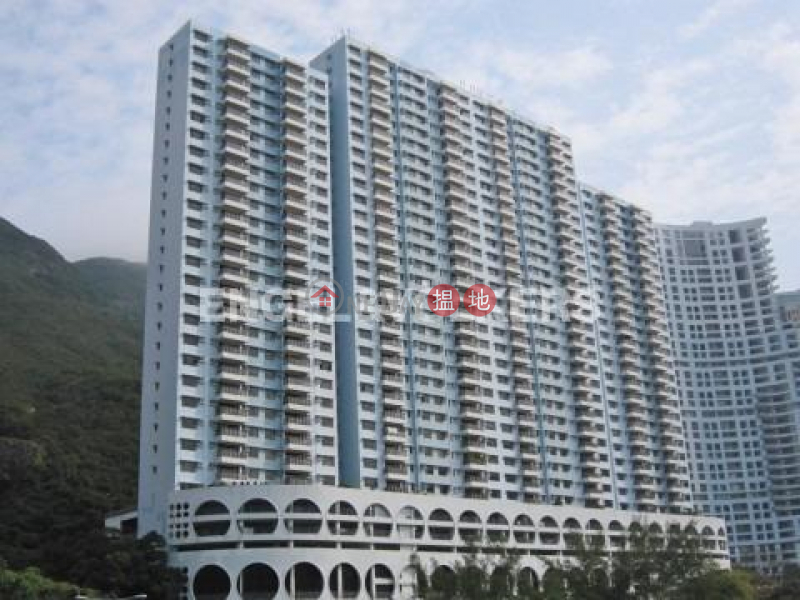What type of climate might this area have, based on the vegetation and weather visible in the image? The climate in this area likely leans towards a warm and possibly humid environmental setting, suggested not only by the lush green vegetation covering the surrounding hills but also by the architectural design of the building, which includes numerous balconies, likely for enjoying mild weather. This type of vegetation typically thrives in climates where temperatures are consistently warm and rainfall is adequate, possibly pointing towards a subtropical climate. However, the presence of such vegetation and architectural styles could also be adapted to various temperate climates. Therefore, while the image suggests a warm climate, nuances like seasonal variations and specific regional characteristics would need more detailed local knowledge or additional data to pinpoint precisely. 